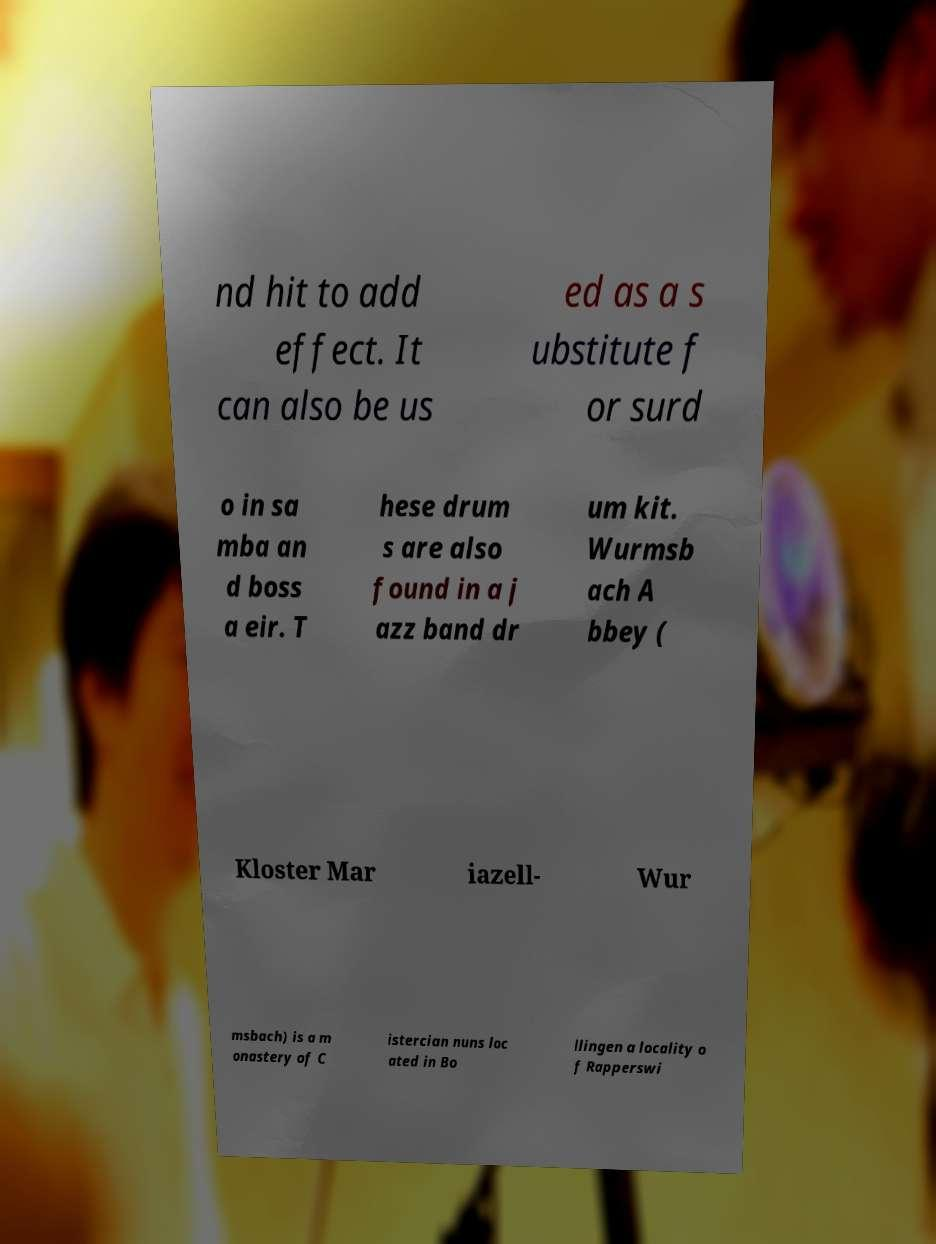There's text embedded in this image that I need extracted. Can you transcribe it verbatim? nd hit to add effect. It can also be us ed as a s ubstitute f or surd o in sa mba an d boss a eir. T hese drum s are also found in a j azz band dr um kit. Wurmsb ach A bbey ( Kloster Mar iazell- Wur msbach) is a m onastery of C istercian nuns loc ated in Bo llingen a locality o f Rapperswi 